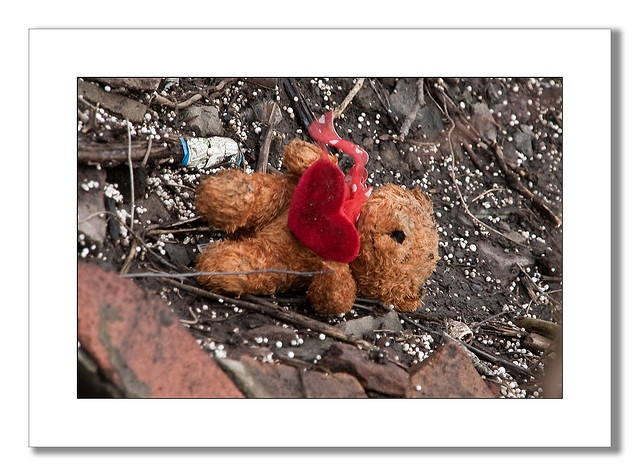Describe the objects in this image and their specific colors. I can see a teddy bear in white, maroon, brown, salmon, and tan tones in this image. 